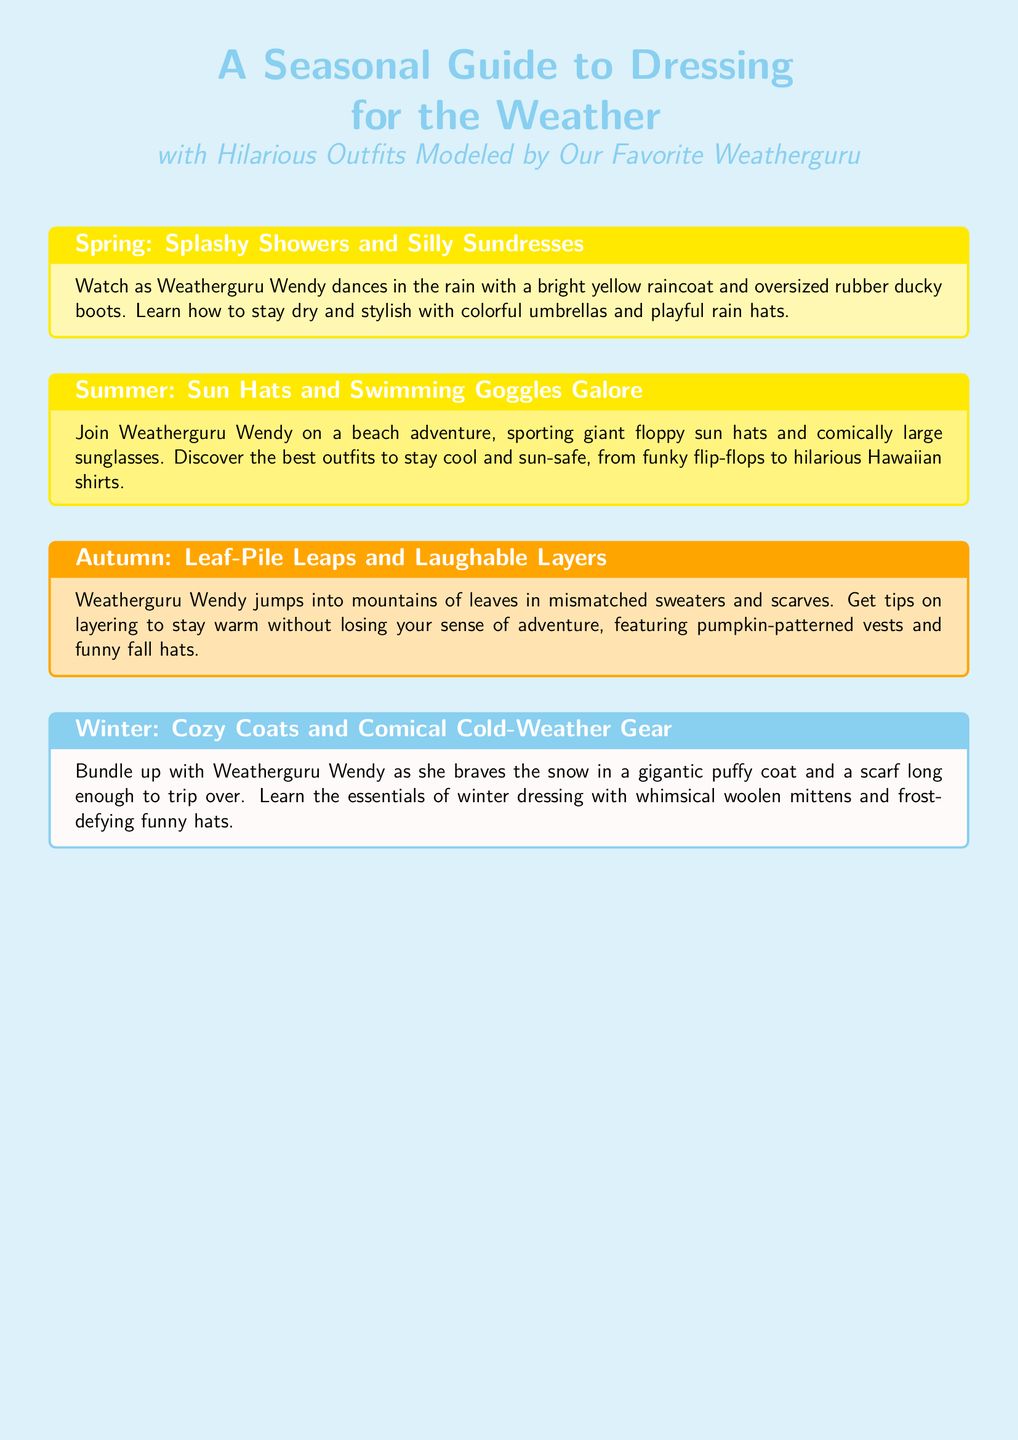What is the title of the guide? The title of the guide is presented prominently at the top of the document as a main heading.
Answer: A Seasonal Guide to Dressing for the Weather Who is modeling the outfits in the guide? The guide mentions a specific character who demonstrates the humorous outfits throughout the seasonal sections.
Answer: Weatherguru Wendy Which season features dancing in the rain? The guide describes a specific activity related to a season, highlighting the playful aspect of dressing for that weather.
Answer: Spring What type of hat is associated with Summer outfits? The Summer section emphasizes a particular kind of hat that aims to protect from the sun while being amusing.
Answer: Giant floppy sun hats What color is the background of the document? The background color is notable and contributes to the visual appeal and theme of the document.
Answer: Baby blue What is a recommended outfit for Autumn? The Autumn section highlights a specific type of clothing that is both fun and practical for the season's conditions.
Answer: Mismatched sweaters and scarves What kind of weather gear is mentioned for Winter? The guide includes a description of a humorous approach to winter clothing in one section.
Answer: Gigantic puffy coat How does Weatherguru Wendy stay dry in Spring? The Spring section includes tips on a specific item that helps stay dry during rainy weather, paired with a fun motif.
Answer: Colorful umbrellas What is noted about the scarf length in Winter outfits? The guide humorously details a feature of the winter outfit that points to a fun and whimsical quality of the clothing.
Answer: Long enough to trip over 